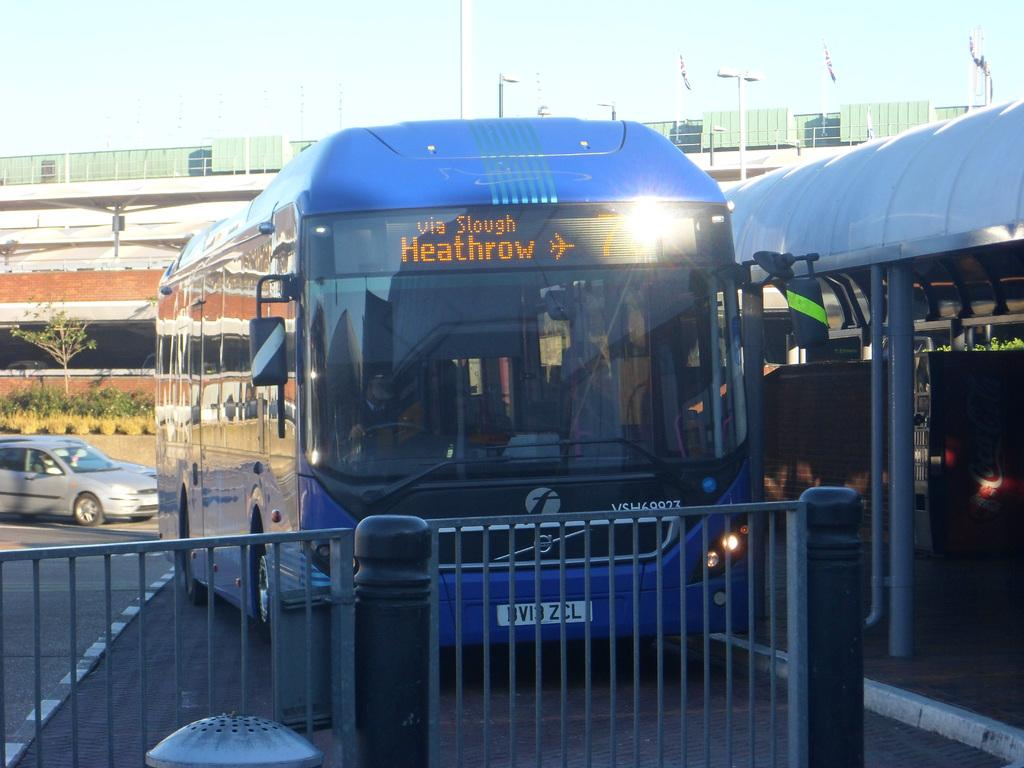<image>
Render a clear and concise summary of the photo. Bus service is available to Heathrow Airport via Slough. 